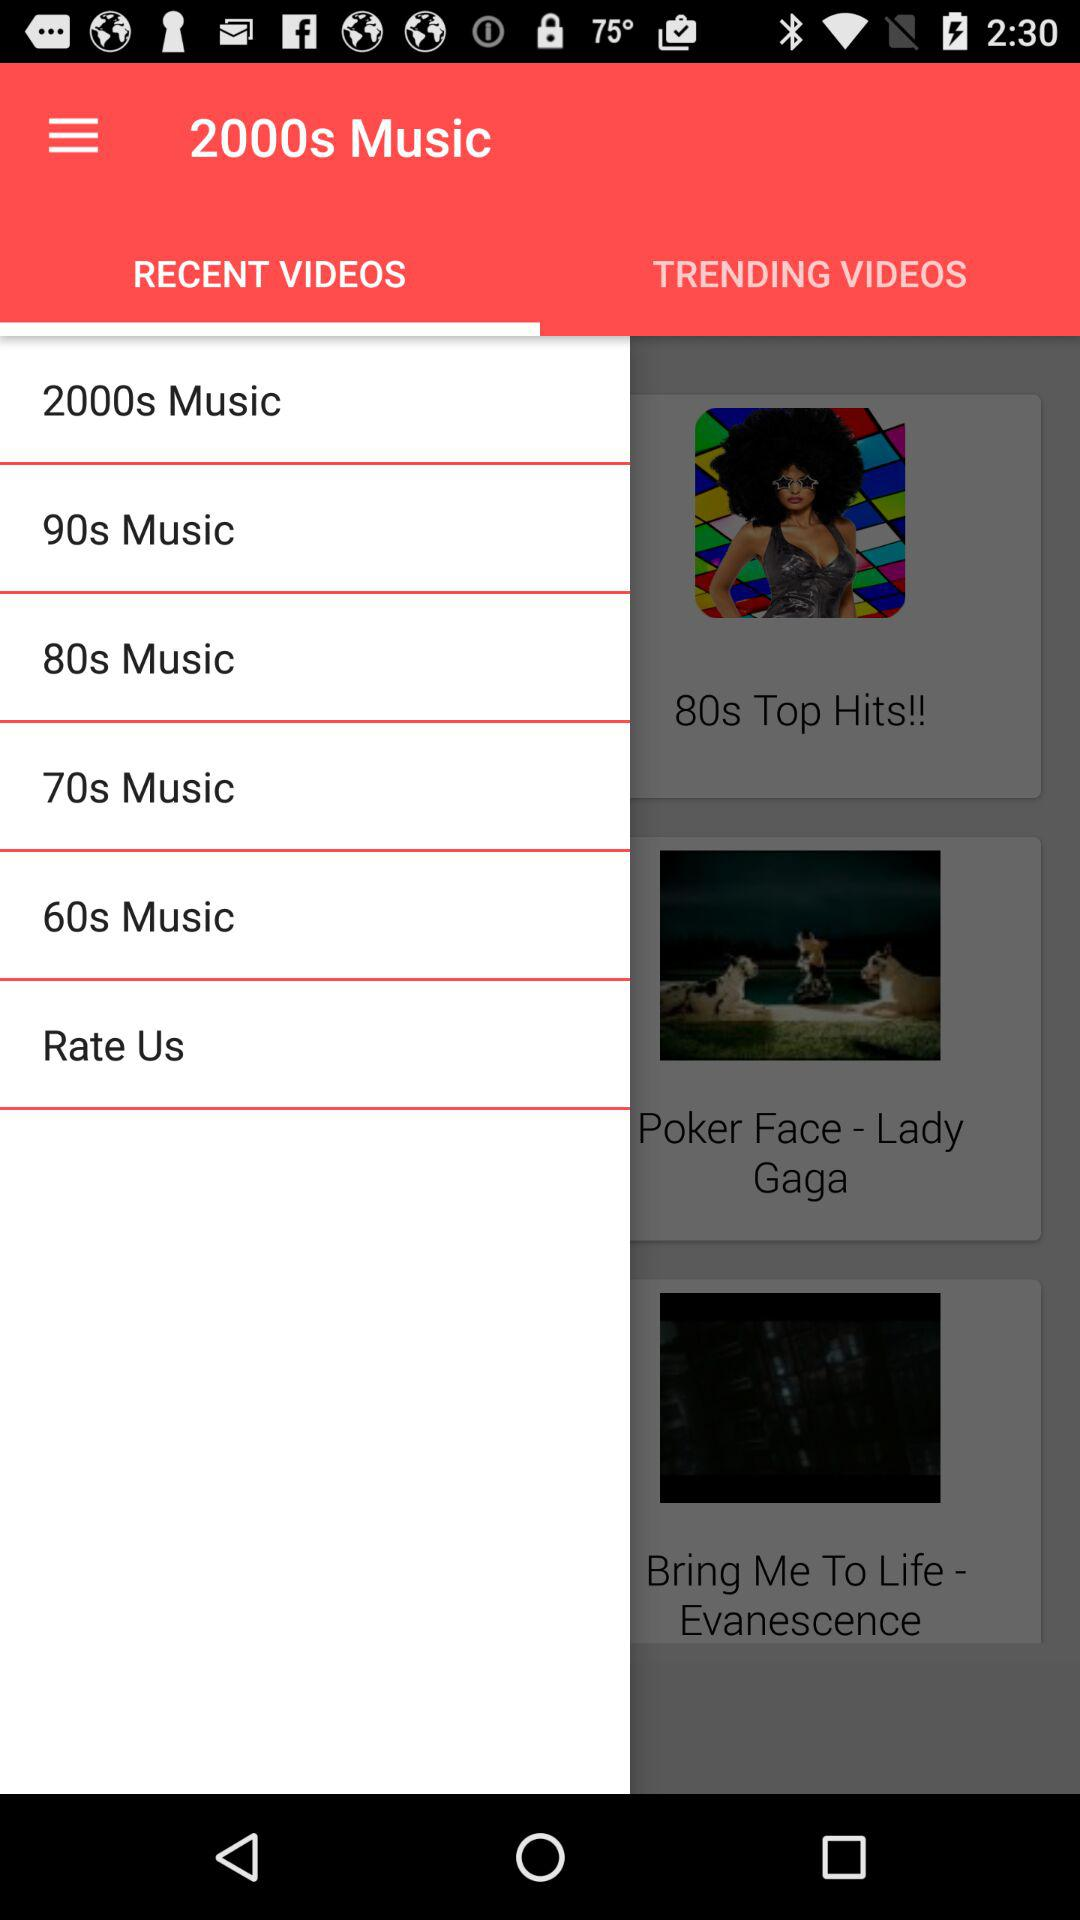Which tab is selected? The selected tab is "RECENT VIDEOS". 